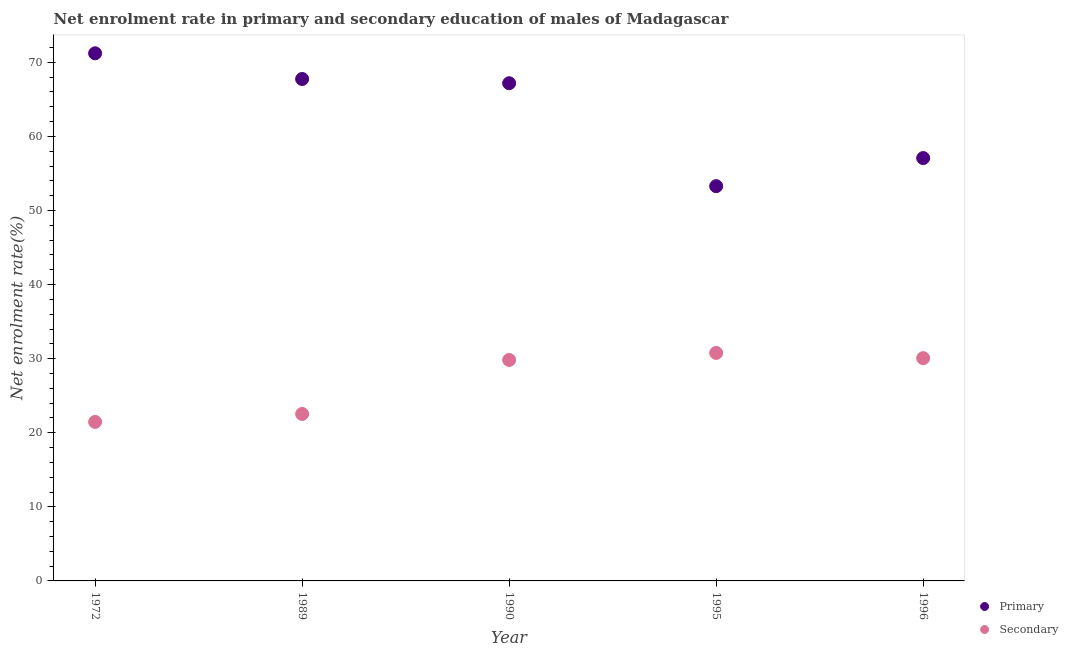Is the number of dotlines equal to the number of legend labels?
Give a very brief answer. Yes. What is the enrollment rate in primary education in 1995?
Give a very brief answer. 53.28. Across all years, what is the maximum enrollment rate in secondary education?
Ensure brevity in your answer.  30.78. Across all years, what is the minimum enrollment rate in primary education?
Offer a very short reply. 53.28. In which year was the enrollment rate in secondary education maximum?
Provide a succinct answer. 1995. What is the total enrollment rate in primary education in the graph?
Ensure brevity in your answer.  316.51. What is the difference between the enrollment rate in secondary education in 1990 and that in 1995?
Offer a terse response. -0.95. What is the difference between the enrollment rate in primary education in 1989 and the enrollment rate in secondary education in 1972?
Provide a short and direct response. 46.29. What is the average enrollment rate in secondary education per year?
Offer a very short reply. 26.93. In the year 1995, what is the difference between the enrollment rate in secondary education and enrollment rate in primary education?
Provide a short and direct response. -22.51. In how many years, is the enrollment rate in primary education greater than 10 %?
Your response must be concise. 5. What is the ratio of the enrollment rate in primary education in 1990 to that in 1996?
Your response must be concise. 1.18. Is the enrollment rate in secondary education in 1990 less than that in 1995?
Your response must be concise. Yes. Is the difference between the enrollment rate in primary education in 1990 and 1996 greater than the difference between the enrollment rate in secondary education in 1990 and 1996?
Provide a succinct answer. Yes. What is the difference between the highest and the second highest enrollment rate in primary education?
Your answer should be compact. 3.47. What is the difference between the highest and the lowest enrollment rate in secondary education?
Your answer should be compact. 9.31. Is the sum of the enrollment rate in secondary education in 1972 and 1996 greater than the maximum enrollment rate in primary education across all years?
Make the answer very short. No. Is the enrollment rate in primary education strictly less than the enrollment rate in secondary education over the years?
Offer a terse response. No. How many dotlines are there?
Offer a very short reply. 2. How many years are there in the graph?
Provide a succinct answer. 5. Are the values on the major ticks of Y-axis written in scientific E-notation?
Offer a terse response. No. How many legend labels are there?
Your answer should be compact. 2. What is the title of the graph?
Offer a terse response. Net enrolment rate in primary and secondary education of males of Madagascar. Does "Primary education" appear as one of the legend labels in the graph?
Ensure brevity in your answer.  No. What is the label or title of the Y-axis?
Give a very brief answer. Net enrolment rate(%). What is the Net enrolment rate(%) of Primary in 1972?
Your answer should be compact. 71.22. What is the Net enrolment rate(%) of Secondary in 1972?
Provide a succinct answer. 21.46. What is the Net enrolment rate(%) of Primary in 1989?
Offer a terse response. 67.75. What is the Net enrolment rate(%) in Secondary in 1989?
Offer a terse response. 22.54. What is the Net enrolment rate(%) of Primary in 1990?
Give a very brief answer. 67.18. What is the Net enrolment rate(%) of Secondary in 1990?
Your response must be concise. 29.83. What is the Net enrolment rate(%) in Primary in 1995?
Your answer should be compact. 53.28. What is the Net enrolment rate(%) in Secondary in 1995?
Your answer should be compact. 30.78. What is the Net enrolment rate(%) in Primary in 1996?
Make the answer very short. 57.08. What is the Net enrolment rate(%) of Secondary in 1996?
Provide a short and direct response. 30.07. Across all years, what is the maximum Net enrolment rate(%) of Primary?
Offer a terse response. 71.22. Across all years, what is the maximum Net enrolment rate(%) of Secondary?
Offer a terse response. 30.78. Across all years, what is the minimum Net enrolment rate(%) of Primary?
Offer a very short reply. 53.28. Across all years, what is the minimum Net enrolment rate(%) in Secondary?
Offer a very short reply. 21.46. What is the total Net enrolment rate(%) of Primary in the graph?
Provide a succinct answer. 316.51. What is the total Net enrolment rate(%) of Secondary in the graph?
Offer a very short reply. 134.67. What is the difference between the Net enrolment rate(%) in Primary in 1972 and that in 1989?
Your answer should be compact. 3.47. What is the difference between the Net enrolment rate(%) of Secondary in 1972 and that in 1989?
Provide a short and direct response. -1.07. What is the difference between the Net enrolment rate(%) in Primary in 1972 and that in 1990?
Your response must be concise. 4.04. What is the difference between the Net enrolment rate(%) in Secondary in 1972 and that in 1990?
Ensure brevity in your answer.  -8.36. What is the difference between the Net enrolment rate(%) of Primary in 1972 and that in 1995?
Offer a terse response. 17.93. What is the difference between the Net enrolment rate(%) of Secondary in 1972 and that in 1995?
Make the answer very short. -9.31. What is the difference between the Net enrolment rate(%) of Primary in 1972 and that in 1996?
Offer a terse response. 14.14. What is the difference between the Net enrolment rate(%) in Secondary in 1972 and that in 1996?
Give a very brief answer. -8.61. What is the difference between the Net enrolment rate(%) in Primary in 1989 and that in 1990?
Your response must be concise. 0.58. What is the difference between the Net enrolment rate(%) in Secondary in 1989 and that in 1990?
Ensure brevity in your answer.  -7.29. What is the difference between the Net enrolment rate(%) of Primary in 1989 and that in 1995?
Make the answer very short. 14.47. What is the difference between the Net enrolment rate(%) of Secondary in 1989 and that in 1995?
Provide a succinct answer. -8.24. What is the difference between the Net enrolment rate(%) in Primary in 1989 and that in 1996?
Offer a terse response. 10.67. What is the difference between the Net enrolment rate(%) in Secondary in 1989 and that in 1996?
Provide a short and direct response. -7.53. What is the difference between the Net enrolment rate(%) of Primary in 1990 and that in 1995?
Your answer should be very brief. 13.89. What is the difference between the Net enrolment rate(%) in Secondary in 1990 and that in 1995?
Keep it short and to the point. -0.95. What is the difference between the Net enrolment rate(%) in Primary in 1990 and that in 1996?
Your answer should be very brief. 10.1. What is the difference between the Net enrolment rate(%) of Secondary in 1990 and that in 1996?
Ensure brevity in your answer.  -0.25. What is the difference between the Net enrolment rate(%) in Primary in 1995 and that in 1996?
Provide a succinct answer. -3.8. What is the difference between the Net enrolment rate(%) in Secondary in 1995 and that in 1996?
Ensure brevity in your answer.  0.7. What is the difference between the Net enrolment rate(%) in Primary in 1972 and the Net enrolment rate(%) in Secondary in 1989?
Provide a short and direct response. 48.68. What is the difference between the Net enrolment rate(%) in Primary in 1972 and the Net enrolment rate(%) in Secondary in 1990?
Your answer should be compact. 41.39. What is the difference between the Net enrolment rate(%) of Primary in 1972 and the Net enrolment rate(%) of Secondary in 1995?
Keep it short and to the point. 40.44. What is the difference between the Net enrolment rate(%) of Primary in 1972 and the Net enrolment rate(%) of Secondary in 1996?
Offer a very short reply. 41.15. What is the difference between the Net enrolment rate(%) in Primary in 1989 and the Net enrolment rate(%) in Secondary in 1990?
Give a very brief answer. 37.93. What is the difference between the Net enrolment rate(%) in Primary in 1989 and the Net enrolment rate(%) in Secondary in 1995?
Make the answer very short. 36.98. What is the difference between the Net enrolment rate(%) in Primary in 1989 and the Net enrolment rate(%) in Secondary in 1996?
Your answer should be very brief. 37.68. What is the difference between the Net enrolment rate(%) in Primary in 1990 and the Net enrolment rate(%) in Secondary in 1995?
Make the answer very short. 36.4. What is the difference between the Net enrolment rate(%) of Primary in 1990 and the Net enrolment rate(%) of Secondary in 1996?
Your response must be concise. 37.1. What is the difference between the Net enrolment rate(%) of Primary in 1995 and the Net enrolment rate(%) of Secondary in 1996?
Your answer should be very brief. 23.21. What is the average Net enrolment rate(%) in Primary per year?
Provide a short and direct response. 63.3. What is the average Net enrolment rate(%) of Secondary per year?
Make the answer very short. 26.93. In the year 1972, what is the difference between the Net enrolment rate(%) of Primary and Net enrolment rate(%) of Secondary?
Your response must be concise. 49.75. In the year 1989, what is the difference between the Net enrolment rate(%) in Primary and Net enrolment rate(%) in Secondary?
Ensure brevity in your answer.  45.21. In the year 1990, what is the difference between the Net enrolment rate(%) in Primary and Net enrolment rate(%) in Secondary?
Your answer should be very brief. 37.35. In the year 1995, what is the difference between the Net enrolment rate(%) of Primary and Net enrolment rate(%) of Secondary?
Ensure brevity in your answer.  22.51. In the year 1996, what is the difference between the Net enrolment rate(%) in Primary and Net enrolment rate(%) in Secondary?
Make the answer very short. 27.01. What is the ratio of the Net enrolment rate(%) of Primary in 1972 to that in 1989?
Provide a succinct answer. 1.05. What is the ratio of the Net enrolment rate(%) of Secondary in 1972 to that in 1989?
Offer a very short reply. 0.95. What is the ratio of the Net enrolment rate(%) in Primary in 1972 to that in 1990?
Your response must be concise. 1.06. What is the ratio of the Net enrolment rate(%) of Secondary in 1972 to that in 1990?
Your response must be concise. 0.72. What is the ratio of the Net enrolment rate(%) of Primary in 1972 to that in 1995?
Make the answer very short. 1.34. What is the ratio of the Net enrolment rate(%) in Secondary in 1972 to that in 1995?
Your response must be concise. 0.7. What is the ratio of the Net enrolment rate(%) of Primary in 1972 to that in 1996?
Provide a succinct answer. 1.25. What is the ratio of the Net enrolment rate(%) in Secondary in 1972 to that in 1996?
Ensure brevity in your answer.  0.71. What is the ratio of the Net enrolment rate(%) in Primary in 1989 to that in 1990?
Provide a short and direct response. 1.01. What is the ratio of the Net enrolment rate(%) of Secondary in 1989 to that in 1990?
Provide a succinct answer. 0.76. What is the ratio of the Net enrolment rate(%) in Primary in 1989 to that in 1995?
Your answer should be very brief. 1.27. What is the ratio of the Net enrolment rate(%) in Secondary in 1989 to that in 1995?
Make the answer very short. 0.73. What is the ratio of the Net enrolment rate(%) in Primary in 1989 to that in 1996?
Your response must be concise. 1.19. What is the ratio of the Net enrolment rate(%) of Secondary in 1989 to that in 1996?
Offer a very short reply. 0.75. What is the ratio of the Net enrolment rate(%) of Primary in 1990 to that in 1995?
Keep it short and to the point. 1.26. What is the ratio of the Net enrolment rate(%) of Secondary in 1990 to that in 1995?
Offer a very short reply. 0.97. What is the ratio of the Net enrolment rate(%) of Primary in 1990 to that in 1996?
Offer a terse response. 1.18. What is the ratio of the Net enrolment rate(%) in Secondary in 1990 to that in 1996?
Your answer should be compact. 0.99. What is the ratio of the Net enrolment rate(%) of Primary in 1995 to that in 1996?
Make the answer very short. 0.93. What is the ratio of the Net enrolment rate(%) of Secondary in 1995 to that in 1996?
Offer a terse response. 1.02. What is the difference between the highest and the second highest Net enrolment rate(%) in Primary?
Your response must be concise. 3.47. What is the difference between the highest and the second highest Net enrolment rate(%) in Secondary?
Give a very brief answer. 0.7. What is the difference between the highest and the lowest Net enrolment rate(%) of Primary?
Your answer should be compact. 17.93. What is the difference between the highest and the lowest Net enrolment rate(%) of Secondary?
Provide a short and direct response. 9.31. 